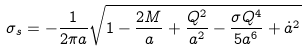<formula> <loc_0><loc_0><loc_500><loc_500>\sigma _ { s } = - \frac { 1 } { 2 \pi a } \sqrt { 1 - \frac { 2 M } { a } + \frac { Q ^ { 2 } } { a ^ { 2 } } - \frac { \sigma Q ^ { 4 } } { 5 a ^ { 6 } } + \dot { a } ^ { 2 } }</formula> 